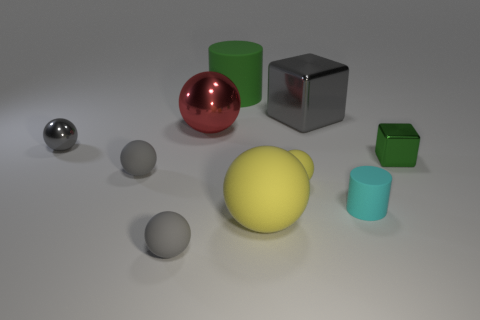Subtract all large matte spheres. How many spheres are left? 5 Subtract all spheres. How many objects are left? 4 Subtract all green cylinders. How many yellow balls are left? 2 Subtract all yellow balls. How many balls are left? 4 Subtract 1 yellow spheres. How many objects are left? 9 Subtract 5 spheres. How many spheres are left? 1 Subtract all brown cylinders. Subtract all brown spheres. How many cylinders are left? 2 Subtract all large gray blocks. Subtract all gray things. How many objects are left? 5 Add 6 large red shiny balls. How many large red shiny balls are left? 7 Add 8 blocks. How many blocks exist? 10 